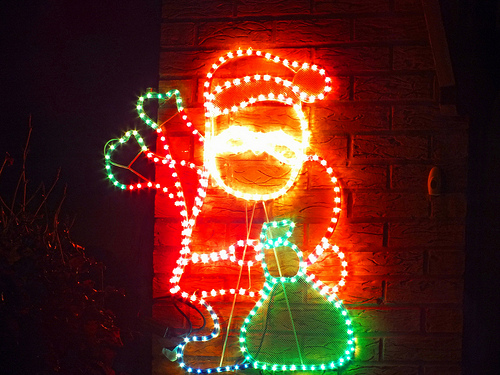<image>
Can you confirm if the sign is behind the wall? No. The sign is not behind the wall. From this viewpoint, the sign appears to be positioned elsewhere in the scene. 